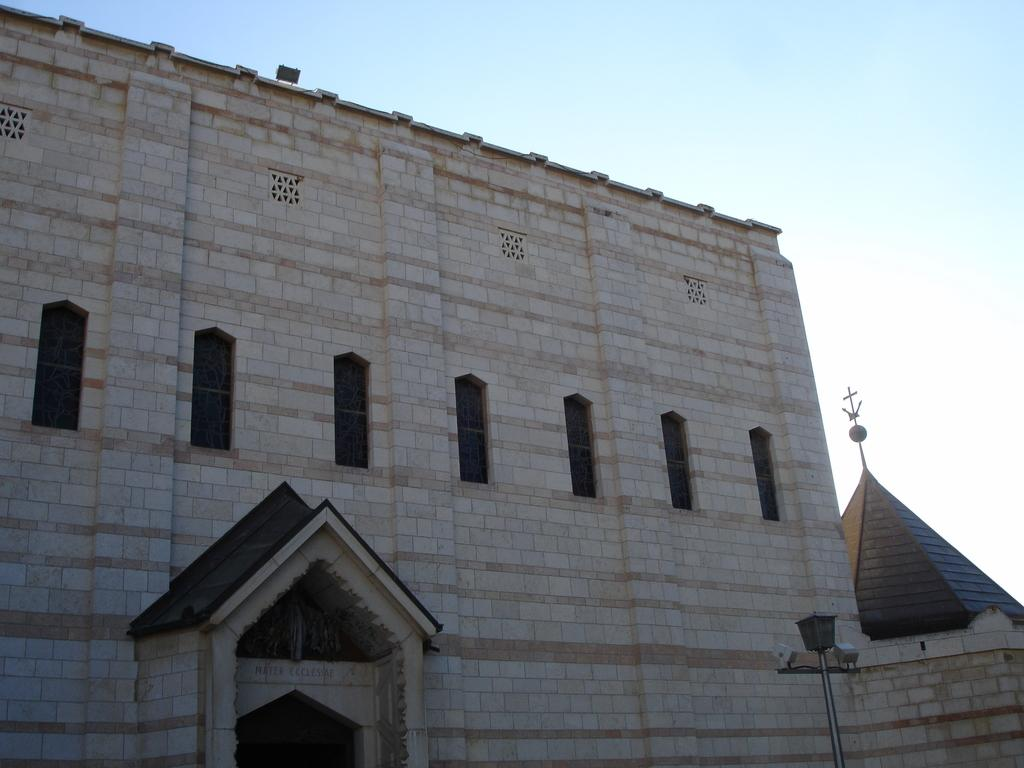What type of structure is present in the image? There is a building in the image. What feature can be seen on the building? The building has windows. What other object is visible in the image? There is a pole in the image. What can be seen in the background of the image? The sky is visible in the background of the image. How is the distribution of knots affecting the stability of the building in the image? There is no mention of knots in the image, and the stability of the building is not discussed. 